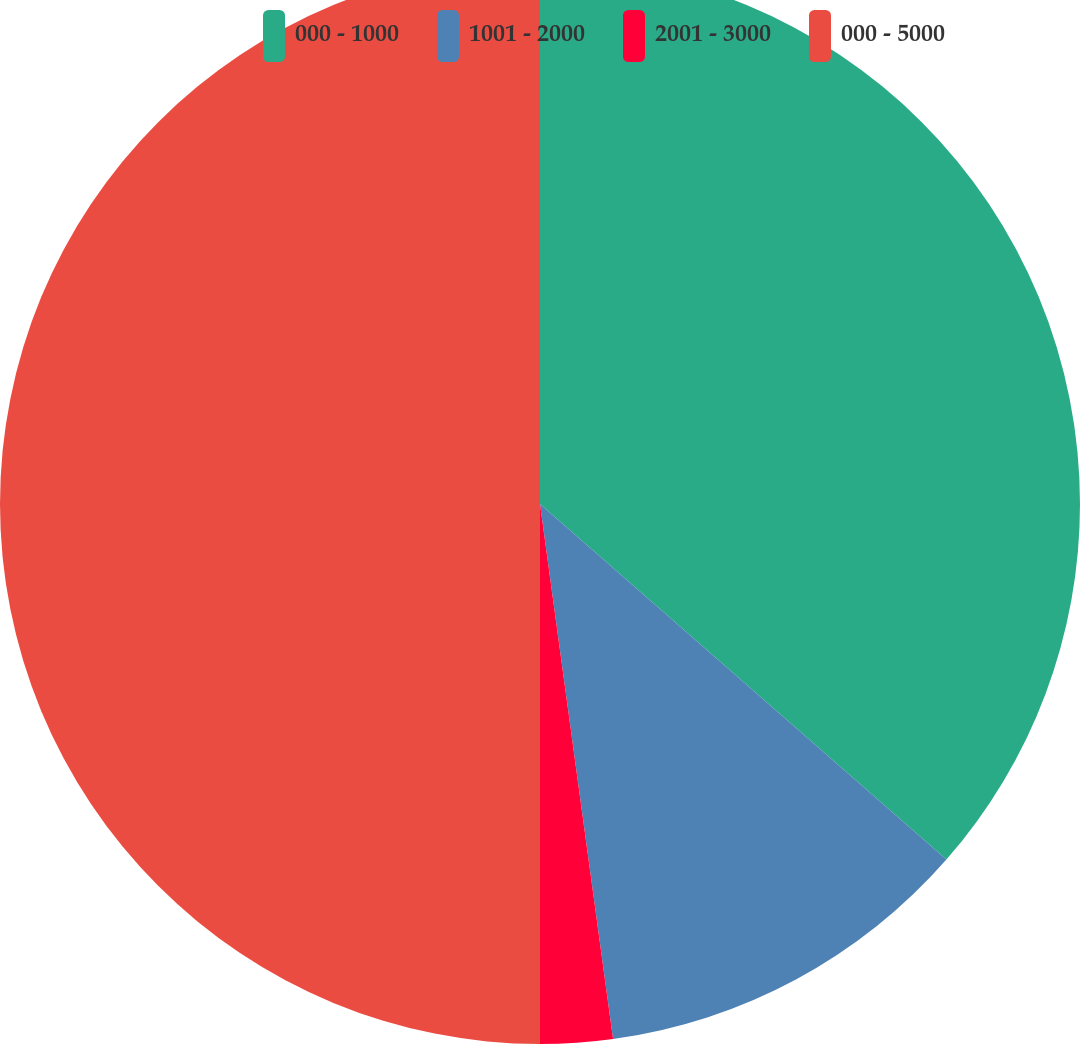<chart> <loc_0><loc_0><loc_500><loc_500><pie_chart><fcel>000 - 1000<fcel>1001 - 2000<fcel>2001 - 3000<fcel>000 - 5000<nl><fcel>36.44%<fcel>11.4%<fcel>2.16%<fcel>50.0%<nl></chart> 